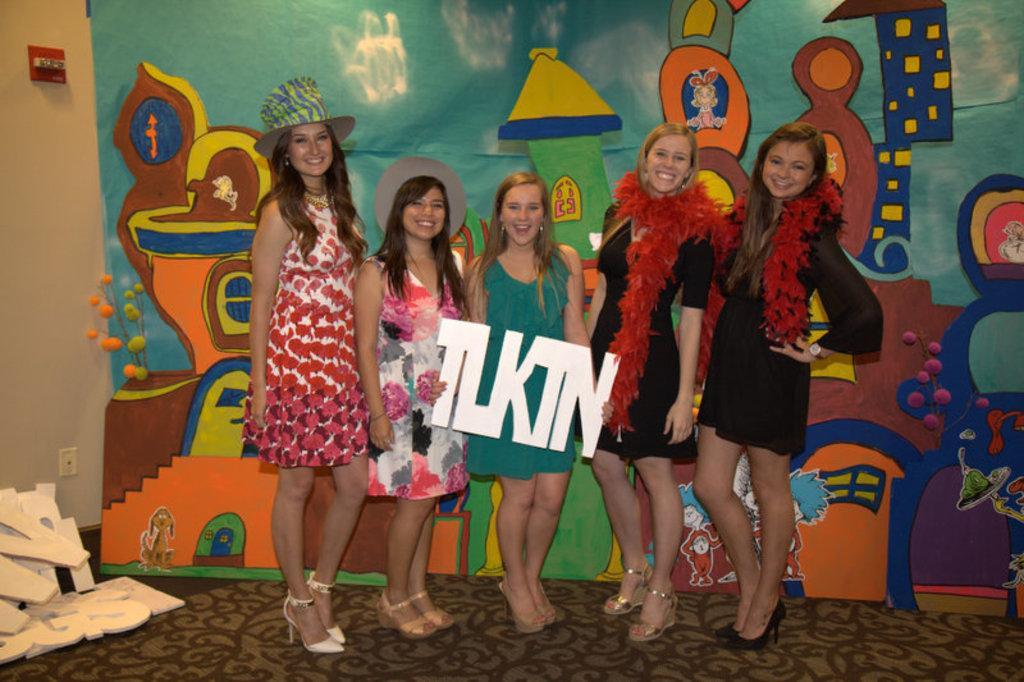How would you summarize this image in a sentence or two? Here I can see few woman standing, smiling and giving pose for the picture. The woman who is in the middle is holding a white color object in the hand. In the bottom left-hand corner there are few letter blocks. At the back of these people there is a board on which I can see some paintings. In the background there is a wall. 